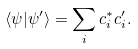<formula> <loc_0><loc_0><loc_500><loc_500>\langle \psi | \psi ^ { \prime } \rangle = \sum _ { i } c _ { i } ^ { * } c _ { i } ^ { \prime } .</formula> 